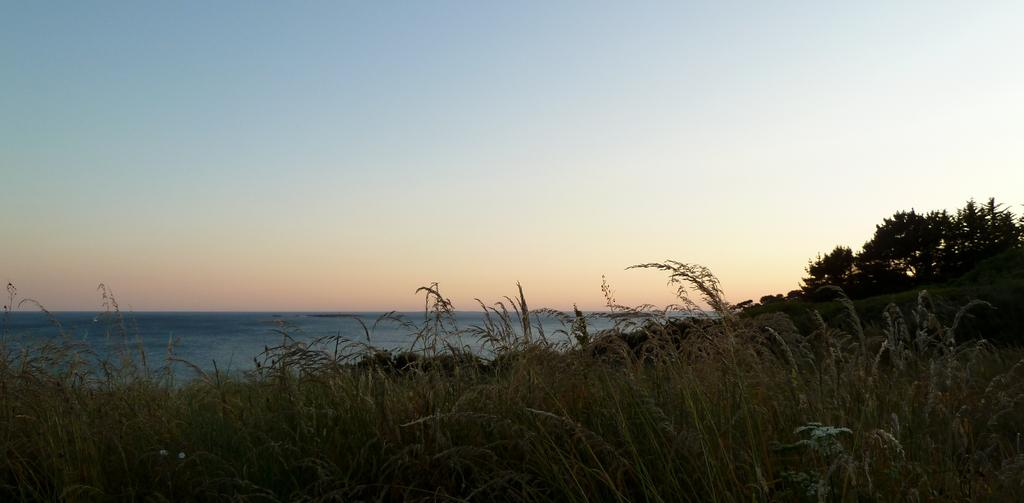What type of vegetation is predominant in the image? There is a lot of grass in the image. What can be seen behind the grass? There are trees behind the grass. What body of water is visible in the image? There is a water surface on the left side of the image. What type of advice can be seen written on the grass in the image? There is no advice written on the grass in the image; it is a natural landscape with grass, trees, and a water surface. 